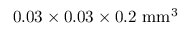<formula> <loc_0><loc_0><loc_500><loc_500>0 . 0 3 \times 0 . 0 3 \times 0 . 2 m m ^ { 3 }</formula> 